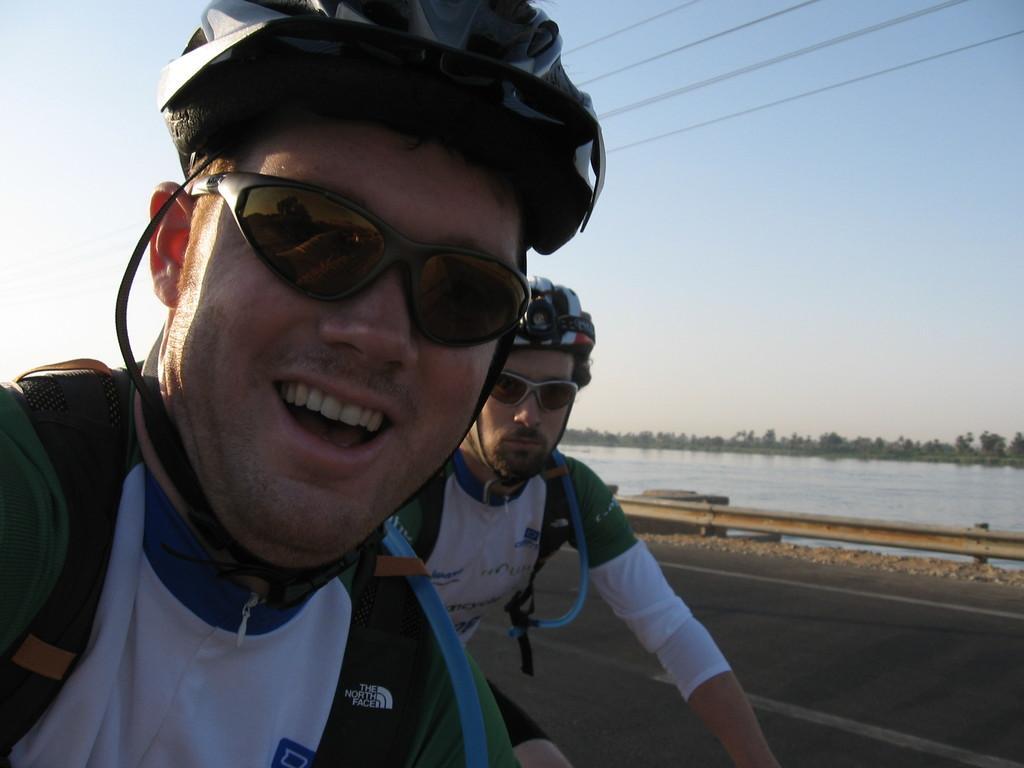In one or two sentences, can you explain what this image depicts? In this image we can see two people riding a bicycle on the road, in the background there is a railing, water, and sky and few wires on the top. 